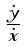Convert formula to latex. <formula><loc_0><loc_0><loc_500><loc_500>\frac { \dot { y } } { \dot { x } }</formula> 